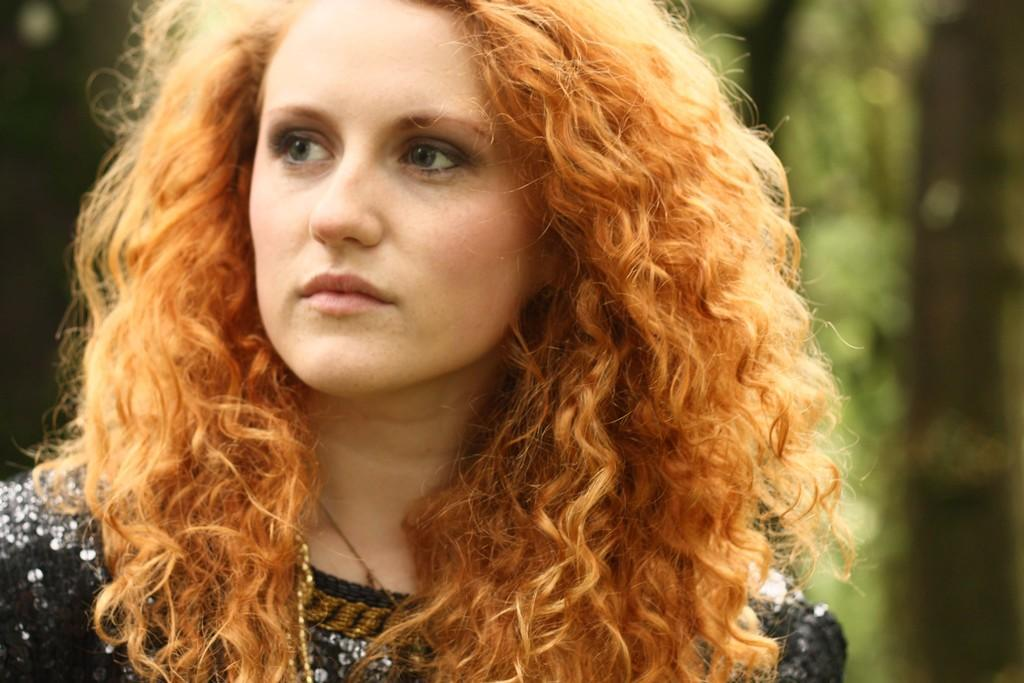What is the main subject of the image? There is a woman in the image. What is the woman wearing? The woman is wearing a black dress. What is the color of the woman's hair? The woman has brown hair. What is the woman doing in the image? The woman is watching something. Can you describe the background of the image? The background of the image is blurred. Can you tell me how the woman controls the air in the image? There is no mention of air control in the image, and the woman is not depicted as having any such ability. 